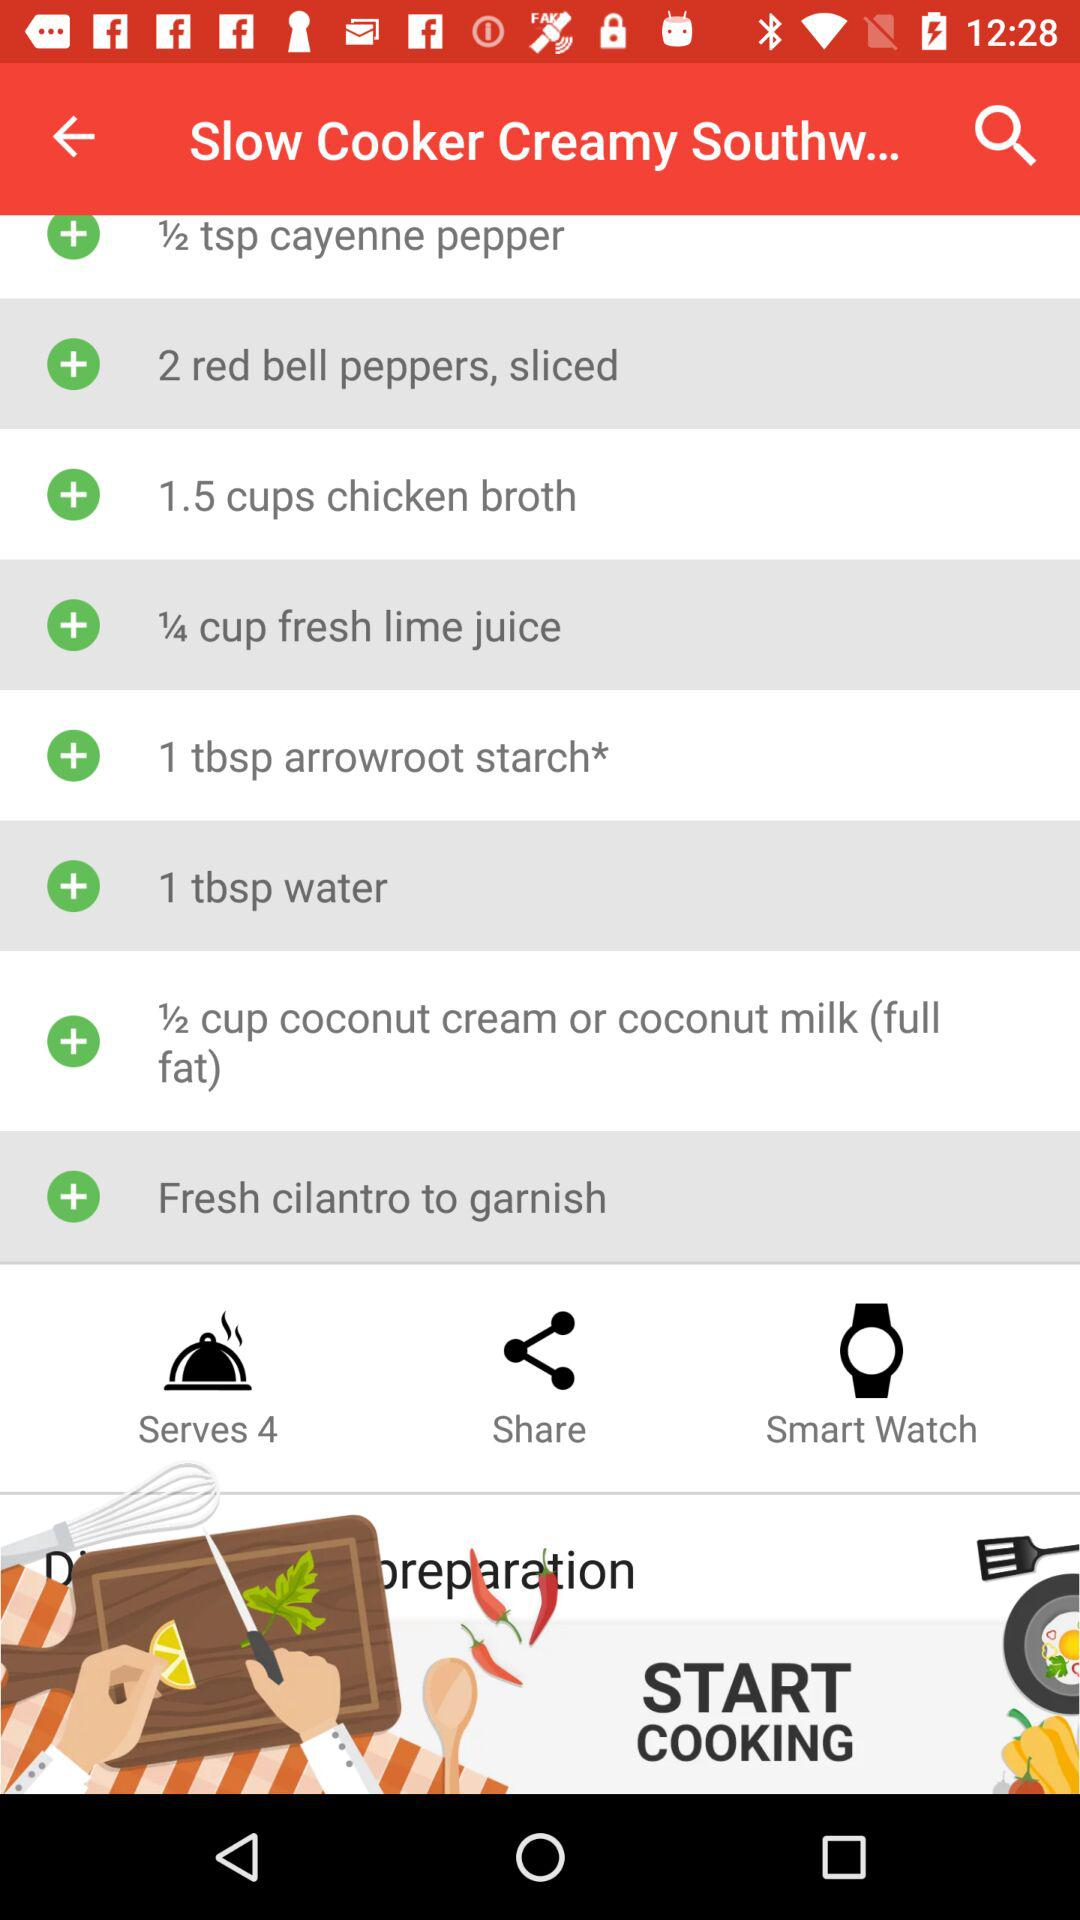How many red bell peppers do we need to make the dish? You need 2 red bell peppers to make the dish. 